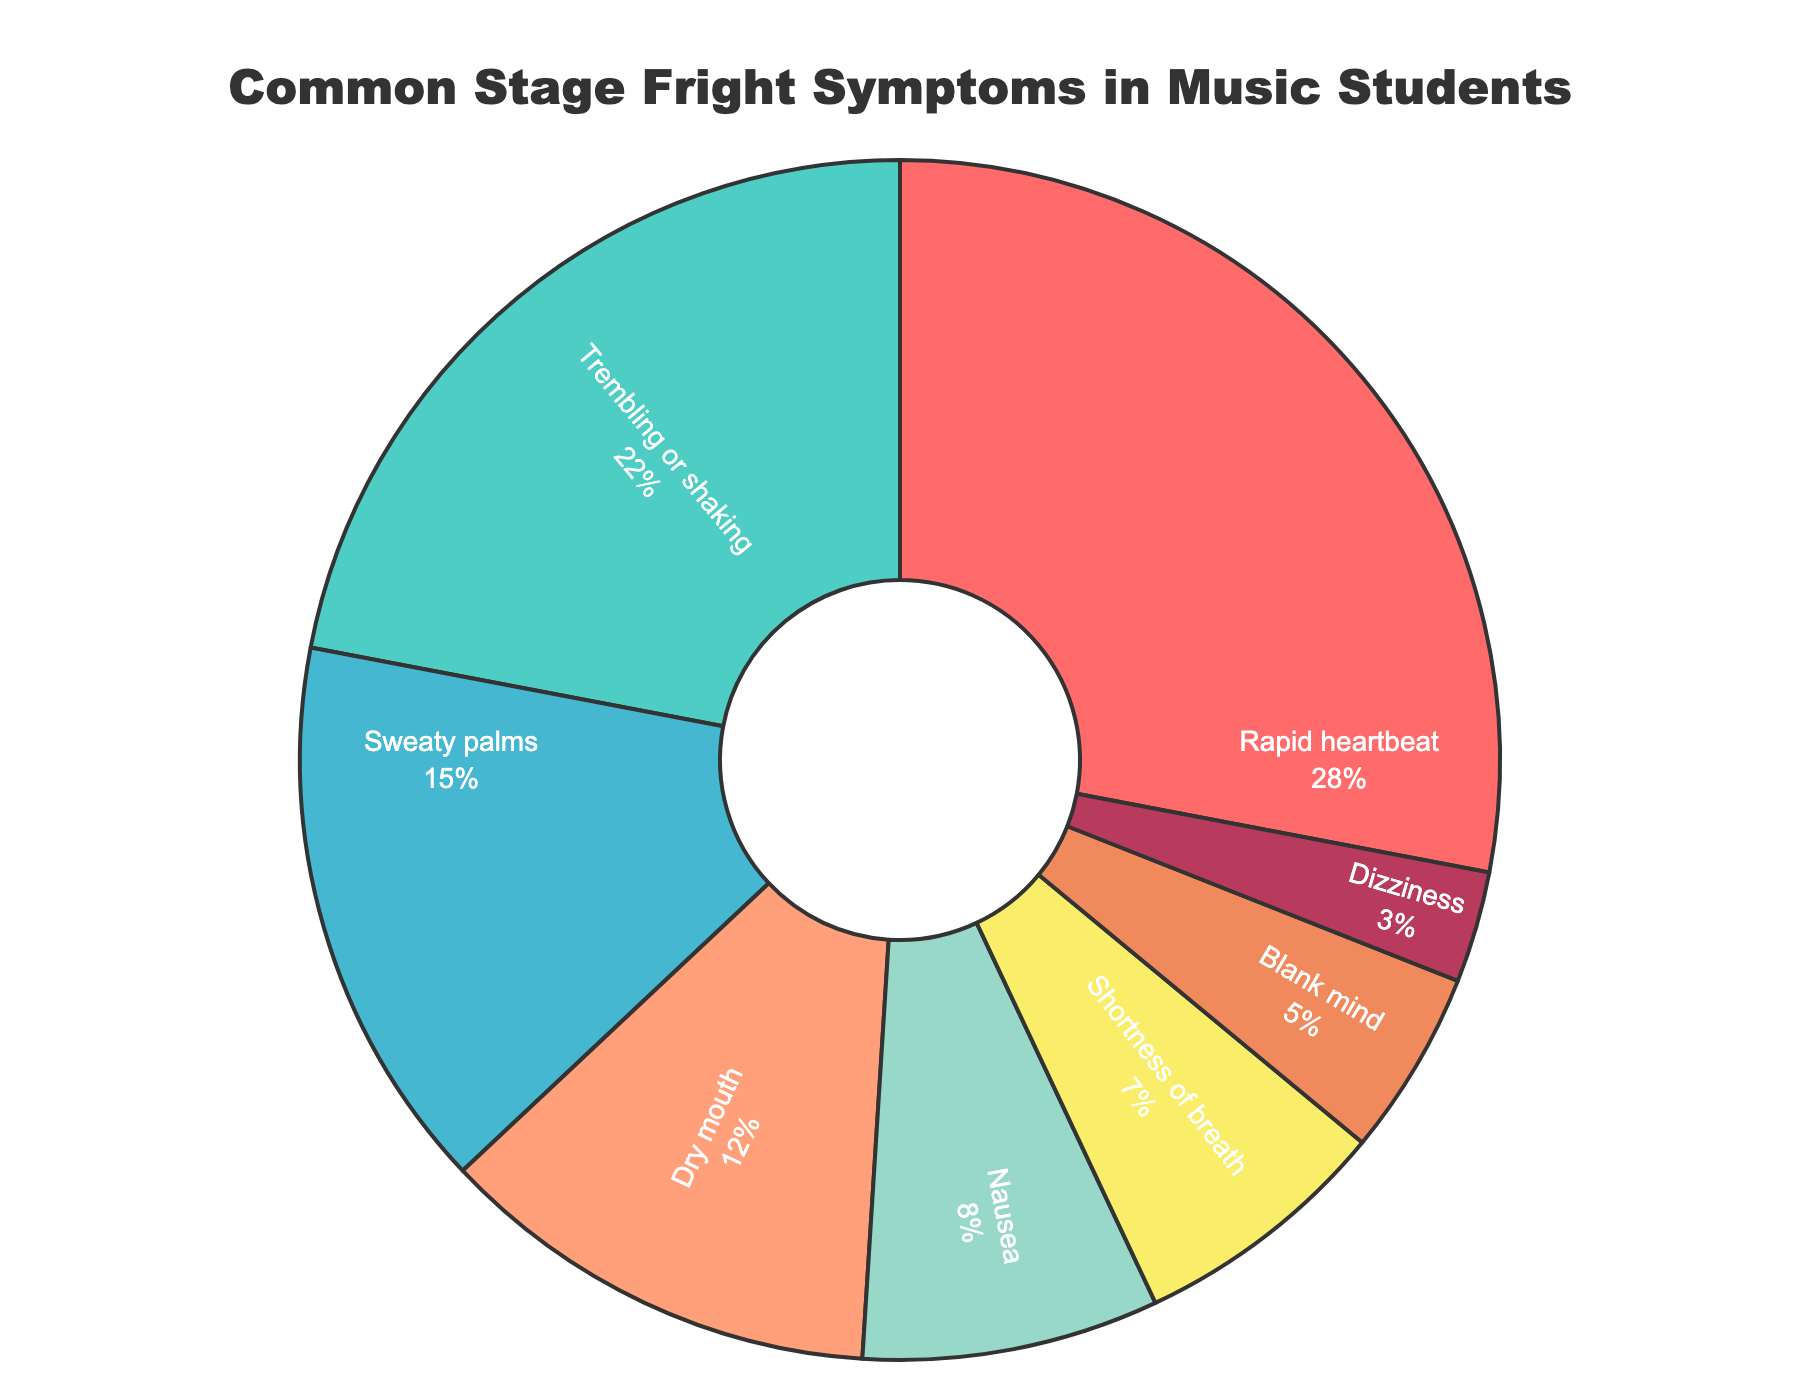What is the most common stage fright symptom among music students? Looking at the pie chart, the largest segment represents "Rapid heartbeat" with the highest percentage.
Answer: Rapid heartbeat Which symptom has a percentage closest to the combined percentage of "Blank mind" and "Dizziness"? First, sum the percentages of "Blank mind" and "Dizziness": 5% + 3% = 8%. Then, look for the segment closest to 8%, which is "Nausea" with 8%.
Answer: Nausea What is the percentage difference between the most and least common stage fright symptoms? The most common symptom is "Rapid heartbeat" with 28%, and the least common is "Dizziness" with 3%. The difference is 28% - 3% = 25%.
Answer: 25% Which colors correspond to the two most common symptoms? The legend shows that "Rapid heartbeat" is associated with red, and "Trembling or shaking" is associated with green.
Answer: Red and green What is the total percentage for symptoms reported by less than 10% of students? Identify symptoms reported by less than 10%: "Nausea" (8%), "Shortness of breath" (7%), "Blank mind" (5%), and "Dizziness" (3%). Sum them up: 8% + 7% + 5% + 3% = 23%.
Answer: 23% How much larger is the percentage for "Sweaty palms" compared to "Blank mind"? "Sweaty palms" have 15%, and "Blank mind" has 5%. The difference is 15% - 5% = 10%.
Answer: 10% Which symptom is represented by the smallest segment in the pie chart? The smallest segment in the pie chart is for "Dizziness," which has 3%.
Answer: Dizziness How do the percentages of "Rapid heartbeat" and "Trembling or shaking" together compare to the combined percentage of all other symptoms? "Rapid heartbeat" is 28% and "Trembling or shaking" is 22%. The combined percentage is 28% + 22% = 50%. The total is 100%, so the other symptoms make up 100% - 50% = 50%.
Answer: Equal Calculate the average percentage of the listed symptoms. Add all percentages: 28% + 22% + 15% + 12% + 8% + 7% + 5% + 3% = 100%. Divide by the number of symptoms (8): 100% / 8 = 12.5%.
Answer: 12.5% 